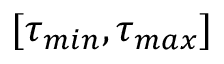<formula> <loc_0><loc_0><loc_500><loc_500>[ \tau _ { \min } , \tau _ { \max } ]</formula> 